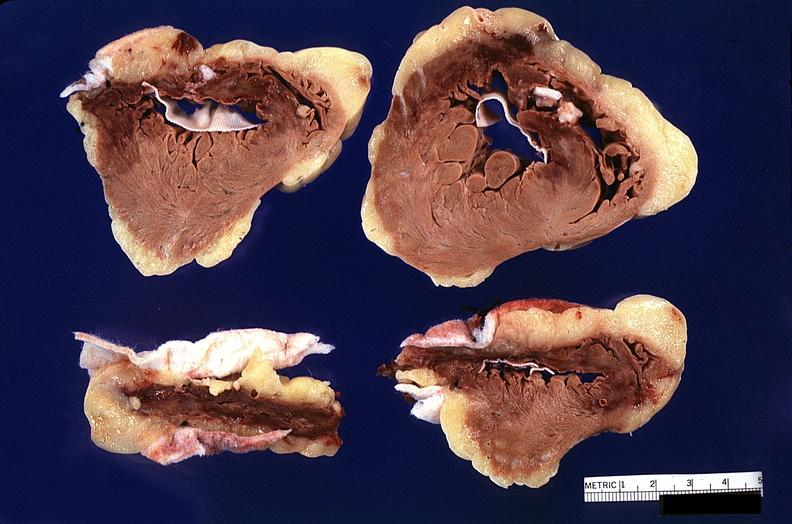where is this?
Answer the question using a single word or phrase. Heart 